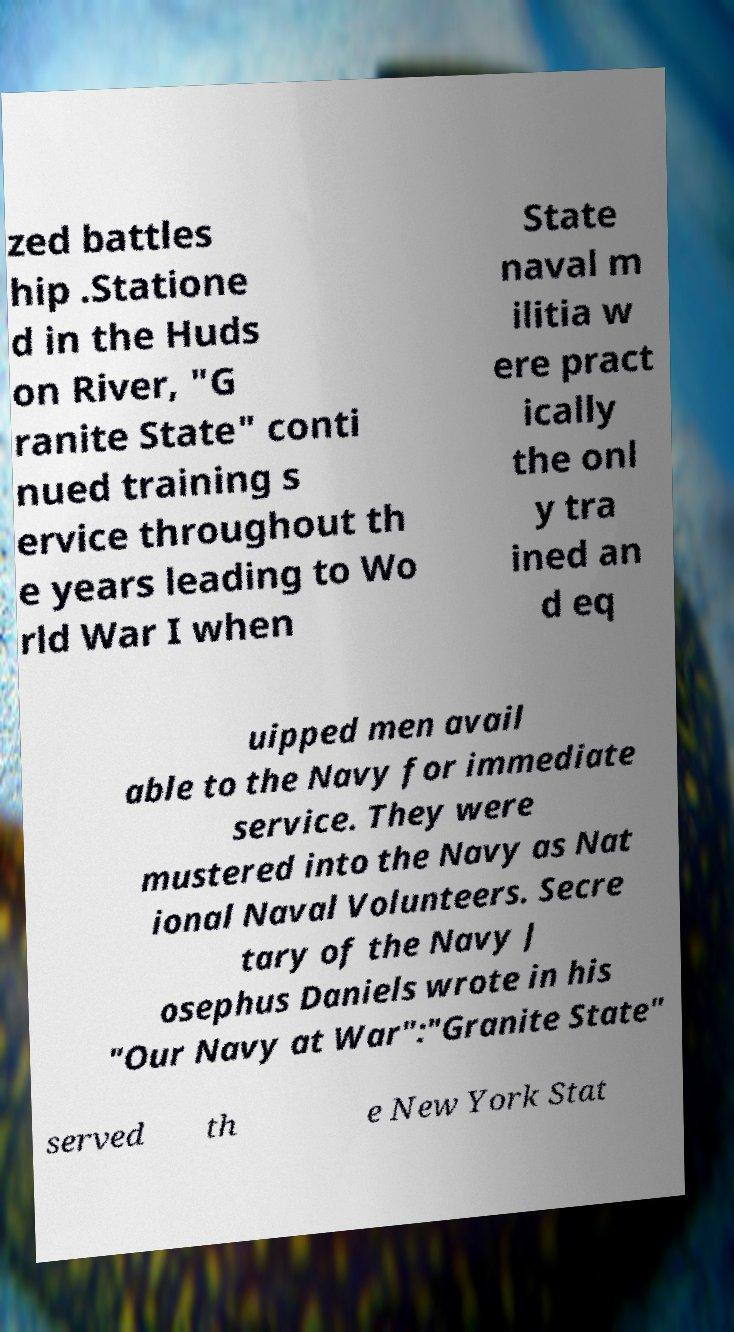I need the written content from this picture converted into text. Can you do that? zed battles hip .Statione d in the Huds on River, "G ranite State" conti nued training s ervice throughout th e years leading to Wo rld War I when State naval m ilitia w ere pract ically the onl y tra ined an d eq uipped men avail able to the Navy for immediate service. They were mustered into the Navy as Nat ional Naval Volunteers. Secre tary of the Navy J osephus Daniels wrote in his "Our Navy at War":"Granite State" served th e New York Stat 